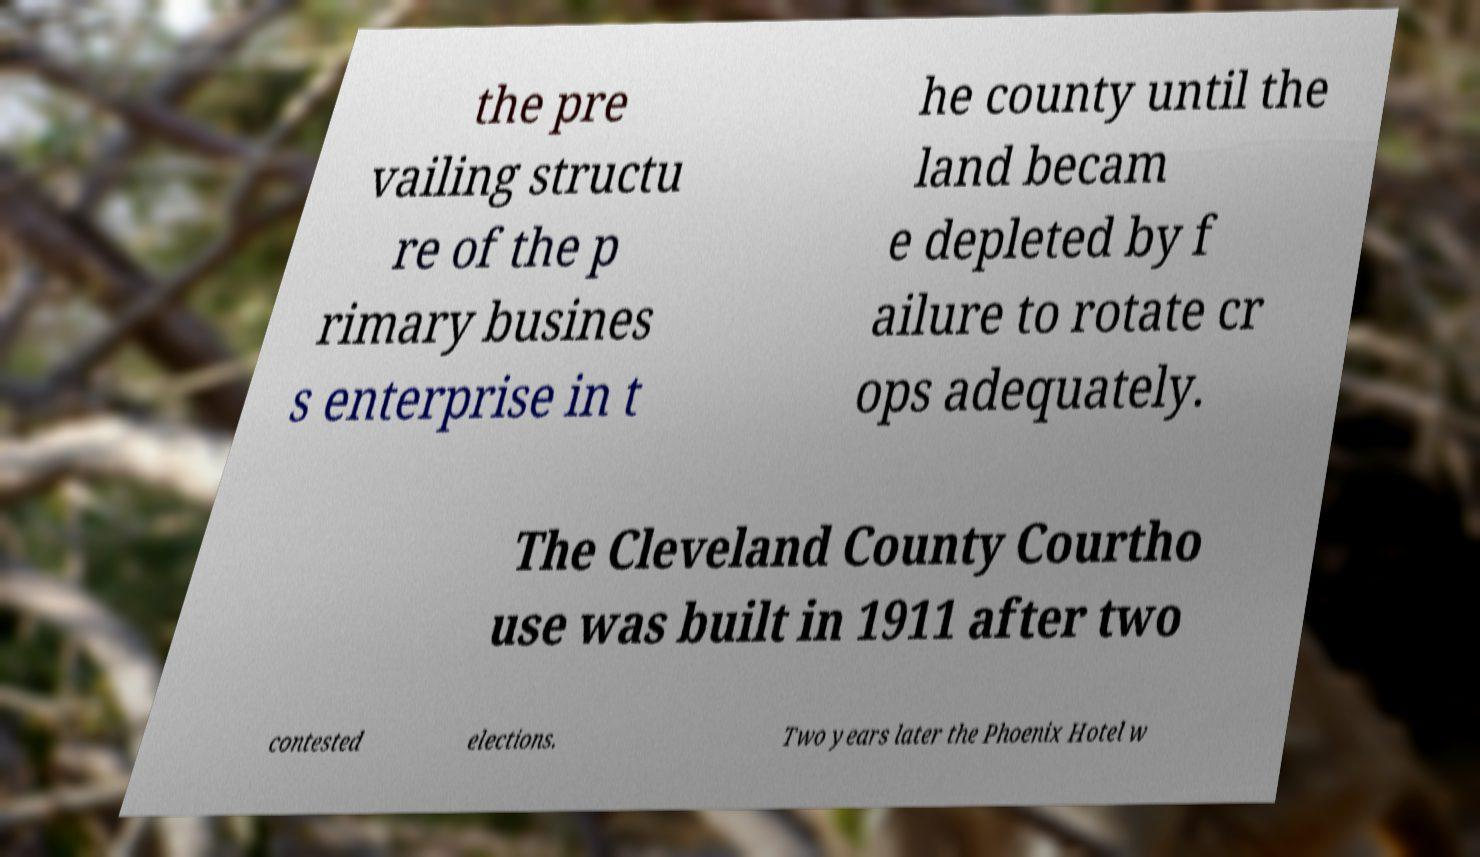Can you read and provide the text displayed in the image?This photo seems to have some interesting text. Can you extract and type it out for me? the pre vailing structu re of the p rimary busines s enterprise in t he county until the land becam e depleted by f ailure to rotate cr ops adequately. The Cleveland County Courtho use was built in 1911 after two contested elections. Two years later the Phoenix Hotel w 